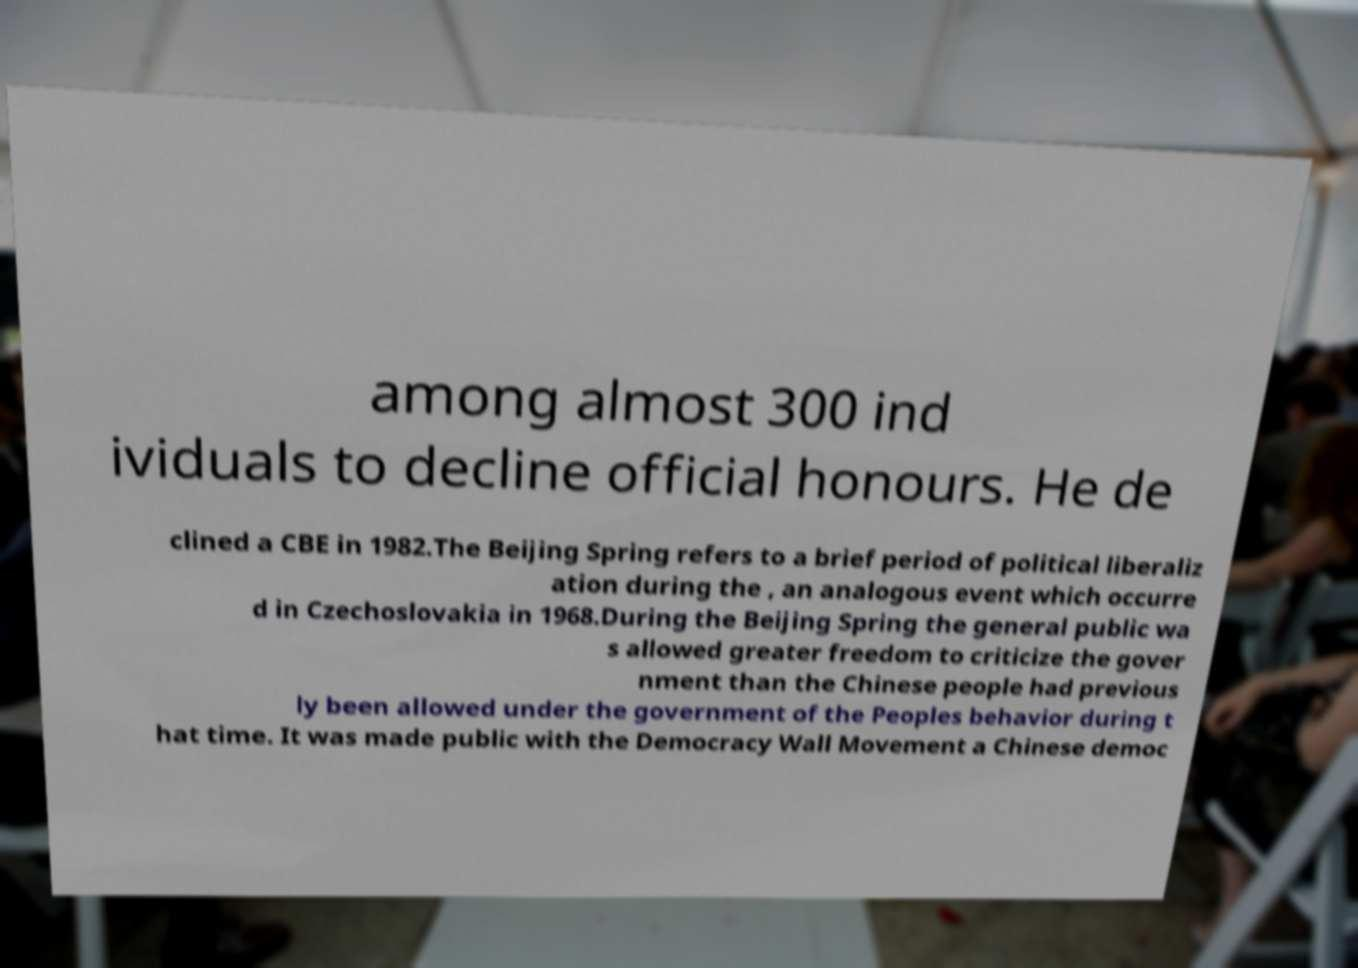What messages or text are displayed in this image? I need them in a readable, typed format. among almost 300 ind ividuals to decline official honours. He de clined a CBE in 1982.The Beijing Spring refers to a brief period of political liberaliz ation during the , an analogous event which occurre d in Czechoslovakia in 1968.During the Beijing Spring the general public wa s allowed greater freedom to criticize the gover nment than the Chinese people had previous ly been allowed under the government of the Peoples behavior during t hat time. It was made public with the Democracy Wall Movement a Chinese democ 